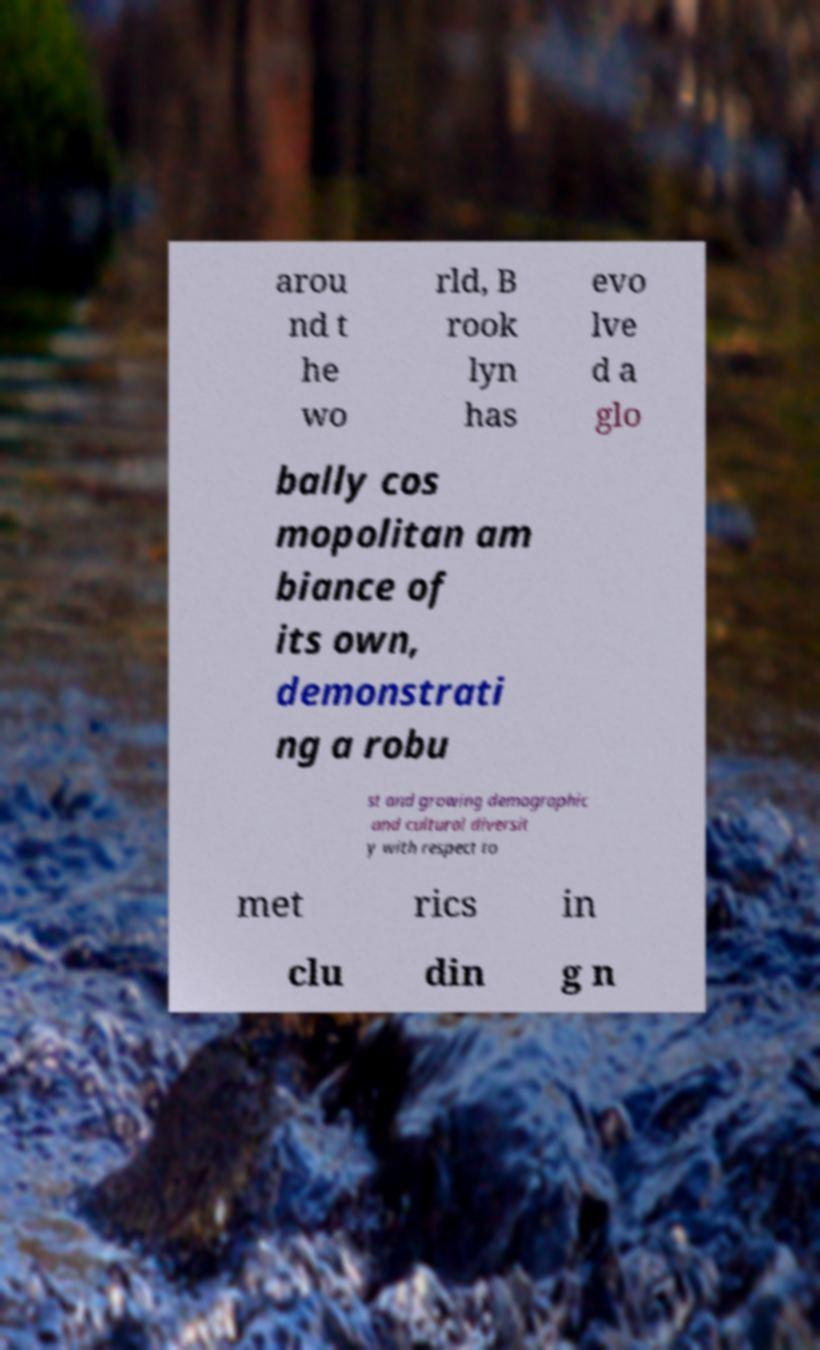Could you assist in decoding the text presented in this image and type it out clearly? arou nd t he wo rld, B rook lyn has evo lve d a glo bally cos mopolitan am biance of its own, demonstrati ng a robu st and growing demographic and cultural diversit y with respect to met rics in clu din g n 